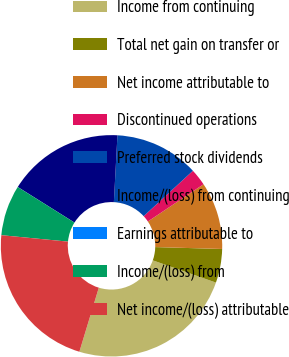<chart> <loc_0><loc_0><loc_500><loc_500><pie_chart><fcel>Income from continuing<fcel>Total net gain on transfer or<fcel>Net income attributable to<fcel>Discontinued operations<fcel>Preferred stock dividends<fcel>Income/(loss) from continuing<fcel>Earnings attributable to<fcel>Income/(loss) from<fcel>Net income/(loss) attributable<nl><fcel>24.3%<fcel>4.93%<fcel>9.84%<fcel>2.47%<fcel>12.29%<fcel>16.93%<fcel>0.01%<fcel>7.38%<fcel>21.84%<nl></chart> 